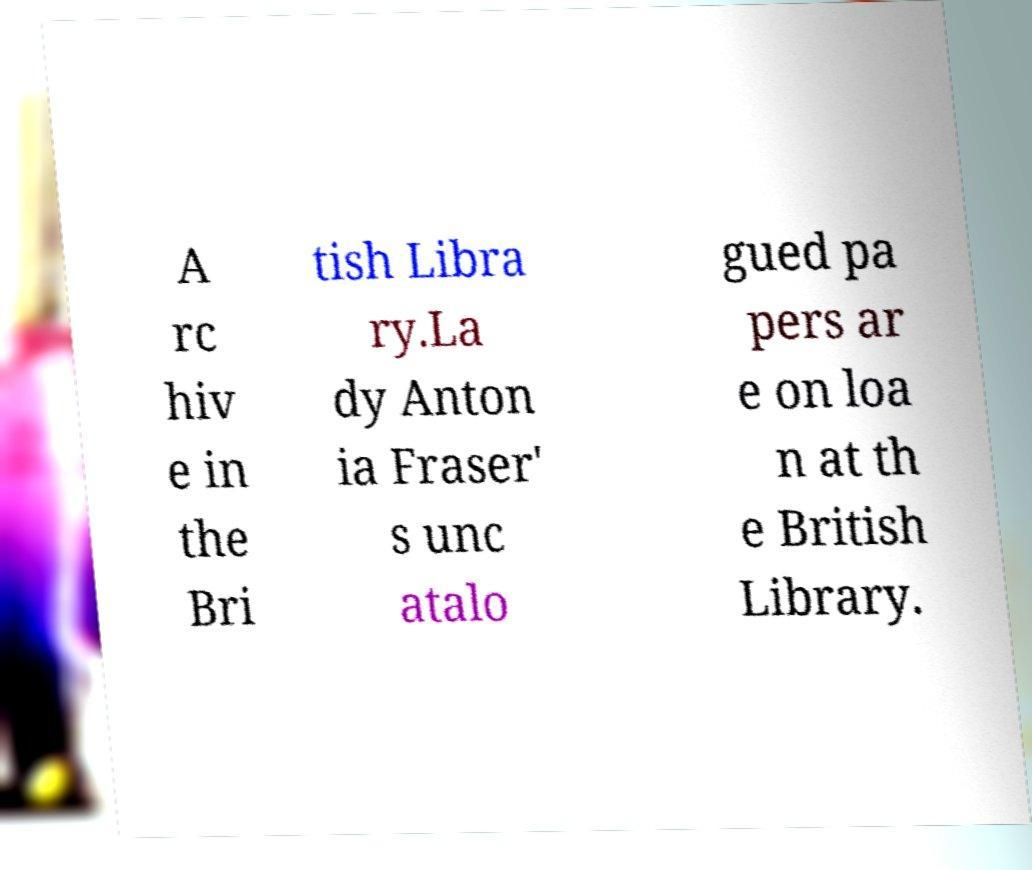Please read and relay the text visible in this image. What does it say? A rc hiv e in the Bri tish Libra ry.La dy Anton ia Fraser' s unc atalo gued pa pers ar e on loa n at th e British Library. 